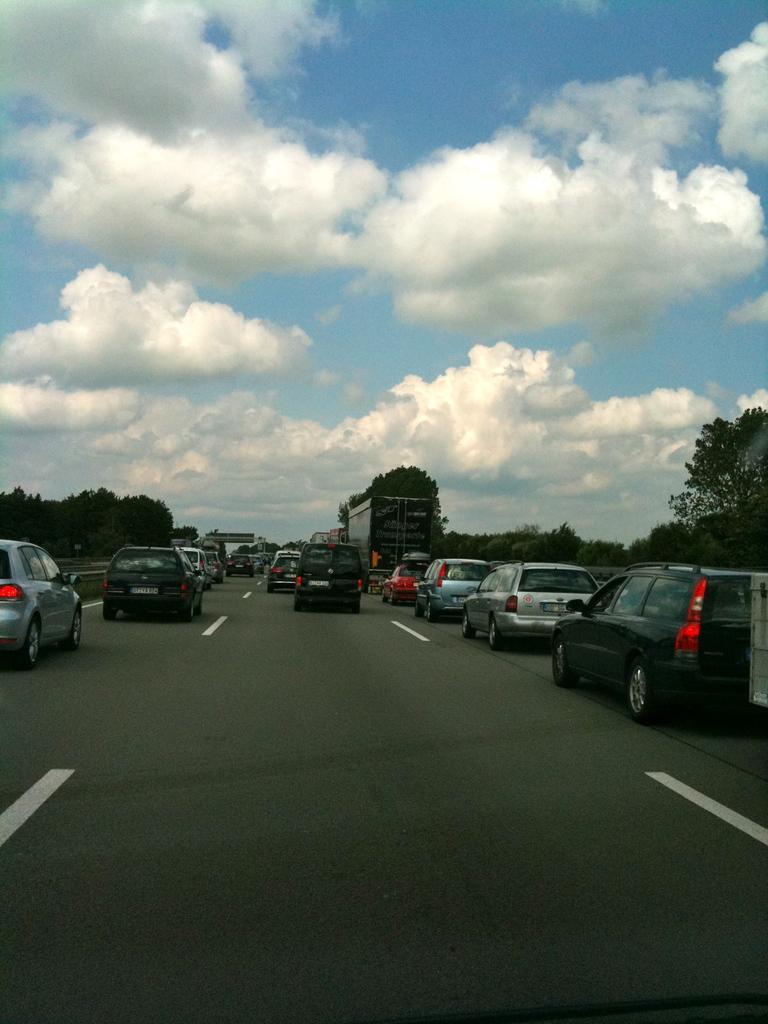Can you describe this image briefly? In this picture we can see few vehicles on the road, in the background we can find few trees and clouds. 